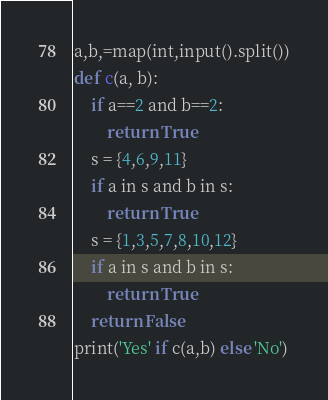<code> <loc_0><loc_0><loc_500><loc_500><_Python_>a,b,=map(int,input().split())
def c(a, b):
    if a==2 and b==2:
        return True
    s = {4,6,9,11}
    if a in s and b in s:
        return True
    s = {1,3,5,7,8,10,12}
    if a in s and b in s:
        return True
    return False
print('Yes' if c(a,b) else 'No')</code> 